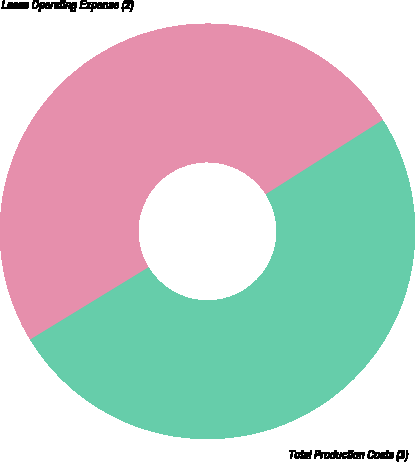Convert chart to OTSL. <chart><loc_0><loc_0><loc_500><loc_500><pie_chart><fcel>Lease Operating Expense (2)<fcel>Total Production Costs (3)<nl><fcel>49.72%<fcel>50.28%<nl></chart> 